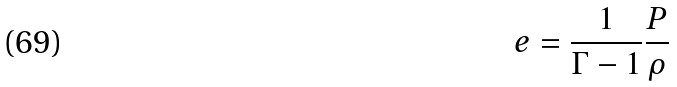<formula> <loc_0><loc_0><loc_500><loc_500>e = \frac { 1 } { \Gamma - 1 } \frac { P } { \rho }</formula> 